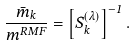Convert formula to latex. <formula><loc_0><loc_0><loc_500><loc_500>\frac { { \bar { m } } _ { k } } { m ^ { R M F } } = \left [ S _ { k } ^ { ( \lambda ) } \right ] ^ { - 1 } .</formula> 